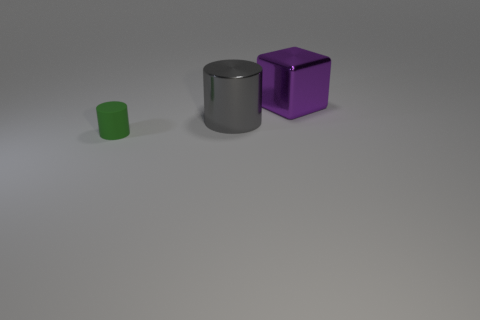What is the color of the other metallic object that is the same size as the purple shiny object?
Ensure brevity in your answer.  Gray. Are there the same number of rubber things behind the small matte thing and gray cylinders that are in front of the big shiny cylinder?
Provide a succinct answer. Yes. What material is the green cylinder that is on the left side of the large object on the right side of the big gray metallic cylinder?
Provide a short and direct response. Rubber. What number of things are big cyan metal spheres or cylinders?
Your answer should be very brief. 2. Is the number of large gray metal cylinders less than the number of shiny things?
Keep it short and to the point. Yes. There is a gray thing that is the same material as the big block; what size is it?
Ensure brevity in your answer.  Large. How big is the purple metallic object?
Offer a terse response. Large. What is the shape of the gray object?
Give a very brief answer. Cylinder. The gray shiny thing that is the same shape as the tiny green thing is what size?
Give a very brief answer. Large. Is there anything else that is made of the same material as the small thing?
Give a very brief answer. No. 